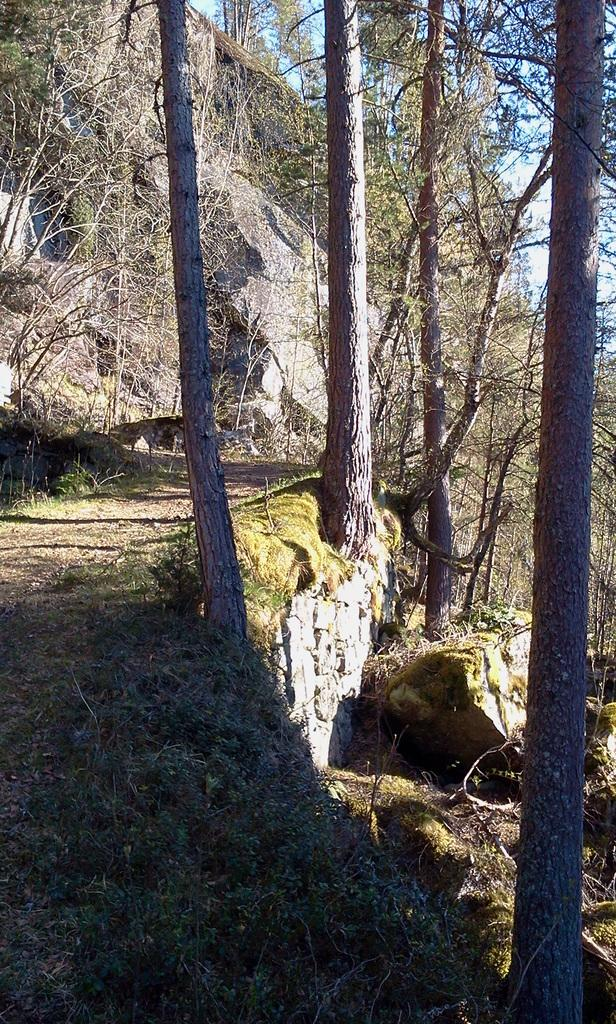What type of vegetation is on the right side of the image? There is a trunk of trees on the right side of the image. What can be seen on the left side of the image? There is a walkway on the left side of the image. What is visible in the background of the image? In the background, there are rocks and trees. Where is the basin located in the image? There is no basin present in the image. Can you see a toad hopping on the walkway in the image? There is no toad present in the image. 